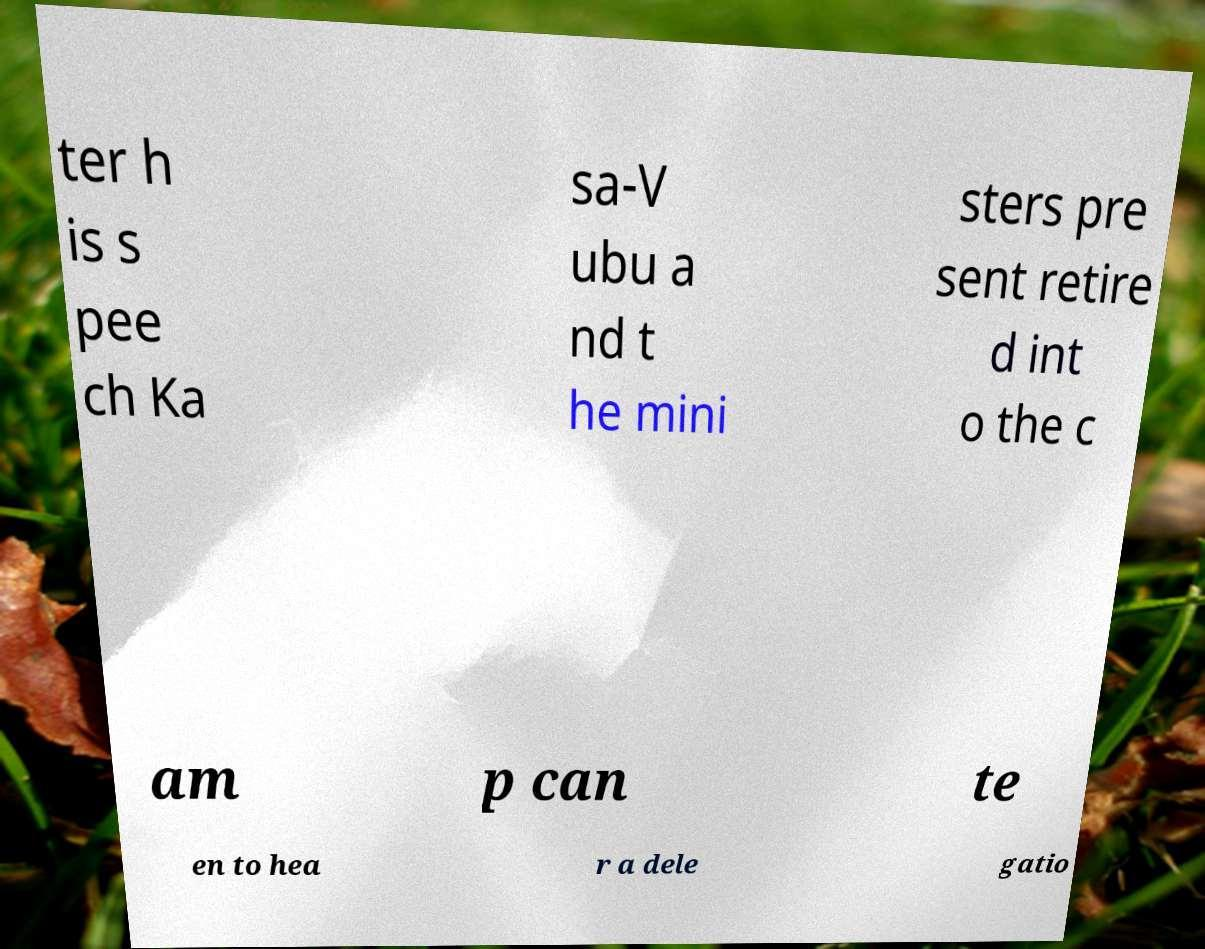Could you extract and type out the text from this image? ter h is s pee ch Ka sa-V ubu a nd t he mini sters pre sent retire d int o the c am p can te en to hea r a dele gatio 